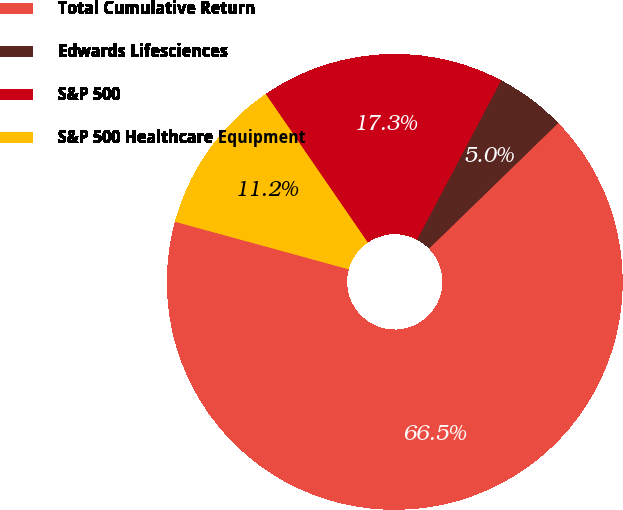<chart> <loc_0><loc_0><loc_500><loc_500><pie_chart><fcel>Total Cumulative Return<fcel>Edwards Lifesciences<fcel>S&P 500<fcel>S&P 500 Healthcare Equipment<nl><fcel>66.53%<fcel>5.0%<fcel>17.31%<fcel>11.16%<nl></chart> 